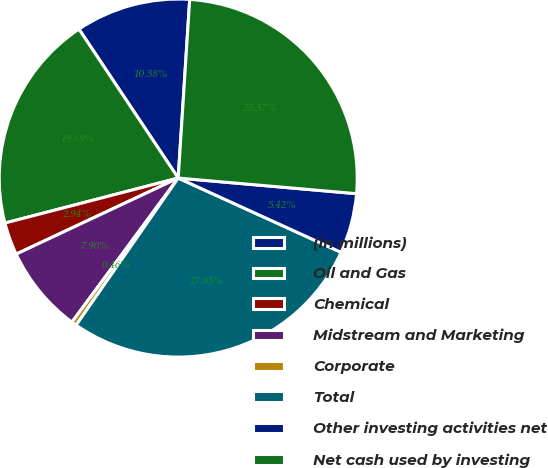Convert chart to OTSL. <chart><loc_0><loc_0><loc_500><loc_500><pie_chart><fcel>(in millions)<fcel>Oil and Gas<fcel>Chemical<fcel>Midstream and Marketing<fcel>Corporate<fcel>Total<fcel>Other investing activities net<fcel>Net cash used by investing<nl><fcel>10.38%<fcel>19.69%<fcel>2.94%<fcel>7.9%<fcel>0.46%<fcel>27.85%<fcel>5.42%<fcel>25.37%<nl></chart> 